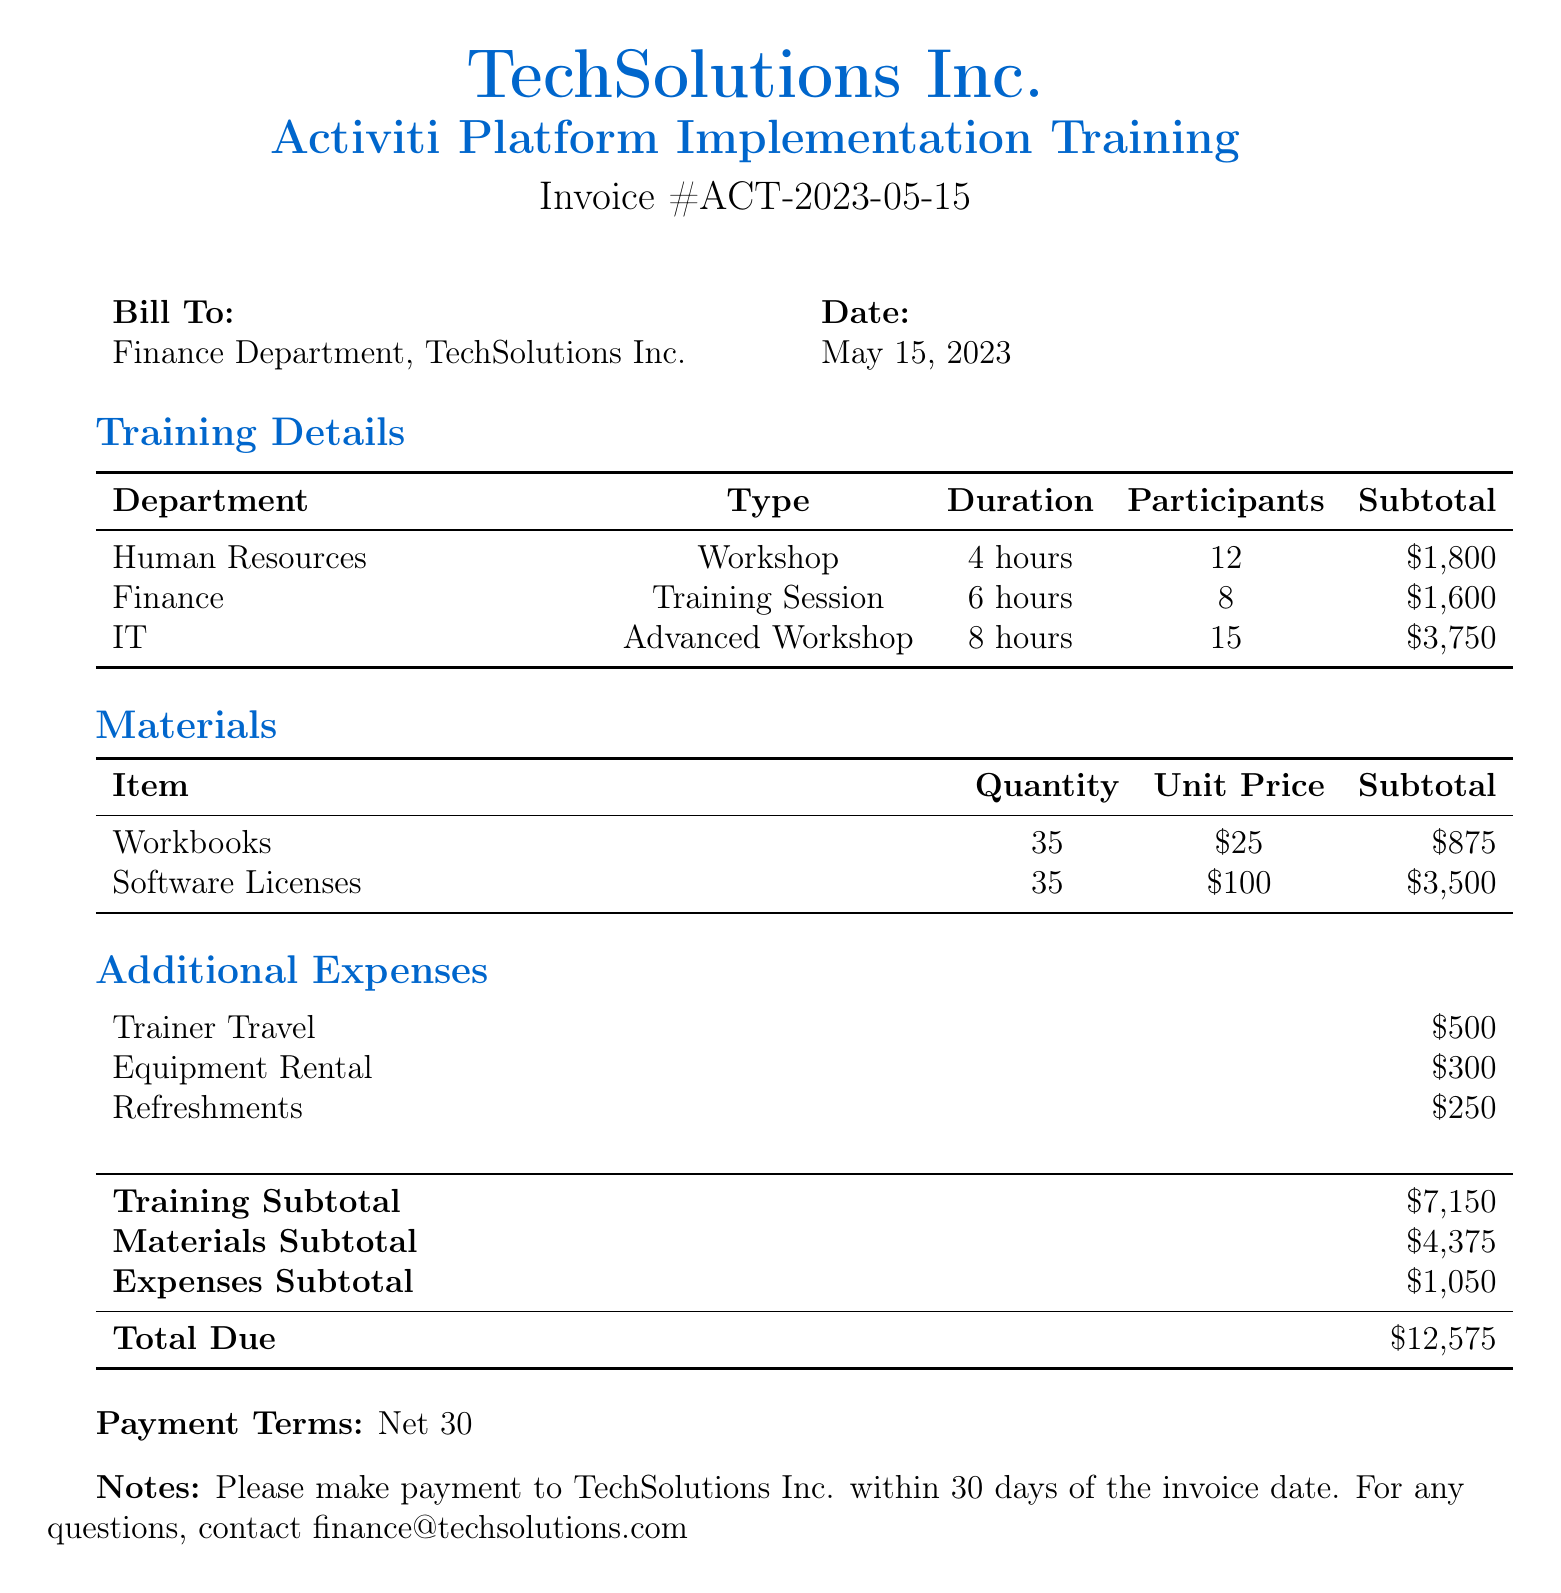what is the invoice number? The invoice number is listed in the document for identification purposes, which is ACT-2023-05-15.
Answer: ACT-2023-05-15 what is the total amount due? The total amount due is calculated from the training subtotal, materials subtotal, and expenses subtotal, resulting in $12,575.
Answer: $12,575 how many participants were in the IT workshop? The number of participants in the IT workshop is specified as 15 in the training details section.
Answer: 15 what is the unit price of workbooks? The unit price for workbooks is listed in the materials section as $25.
Answer: $25 which department had a 8-hour training session? The department that conducted an 8-hour training session is identified in the training details section, which is IT.
Answer: IT how much was spent on trainer travel? The expense for trainer travel is provided in the additional expenses section as $500.
Answer: $500 what is the quantity of software licenses mentioned? The quantity of software licenses is detailed in the materials section, which shows a total of 35.
Answer: 35 how many hours was the finance training session? The duration of the finance training session is indicated in the training details as 6 hours.
Answer: 6 hours what is the payment term set in the document? The payment term specified in the document outlines the duration within which payment should be made, which is 30 days.
Answer: Net 30 